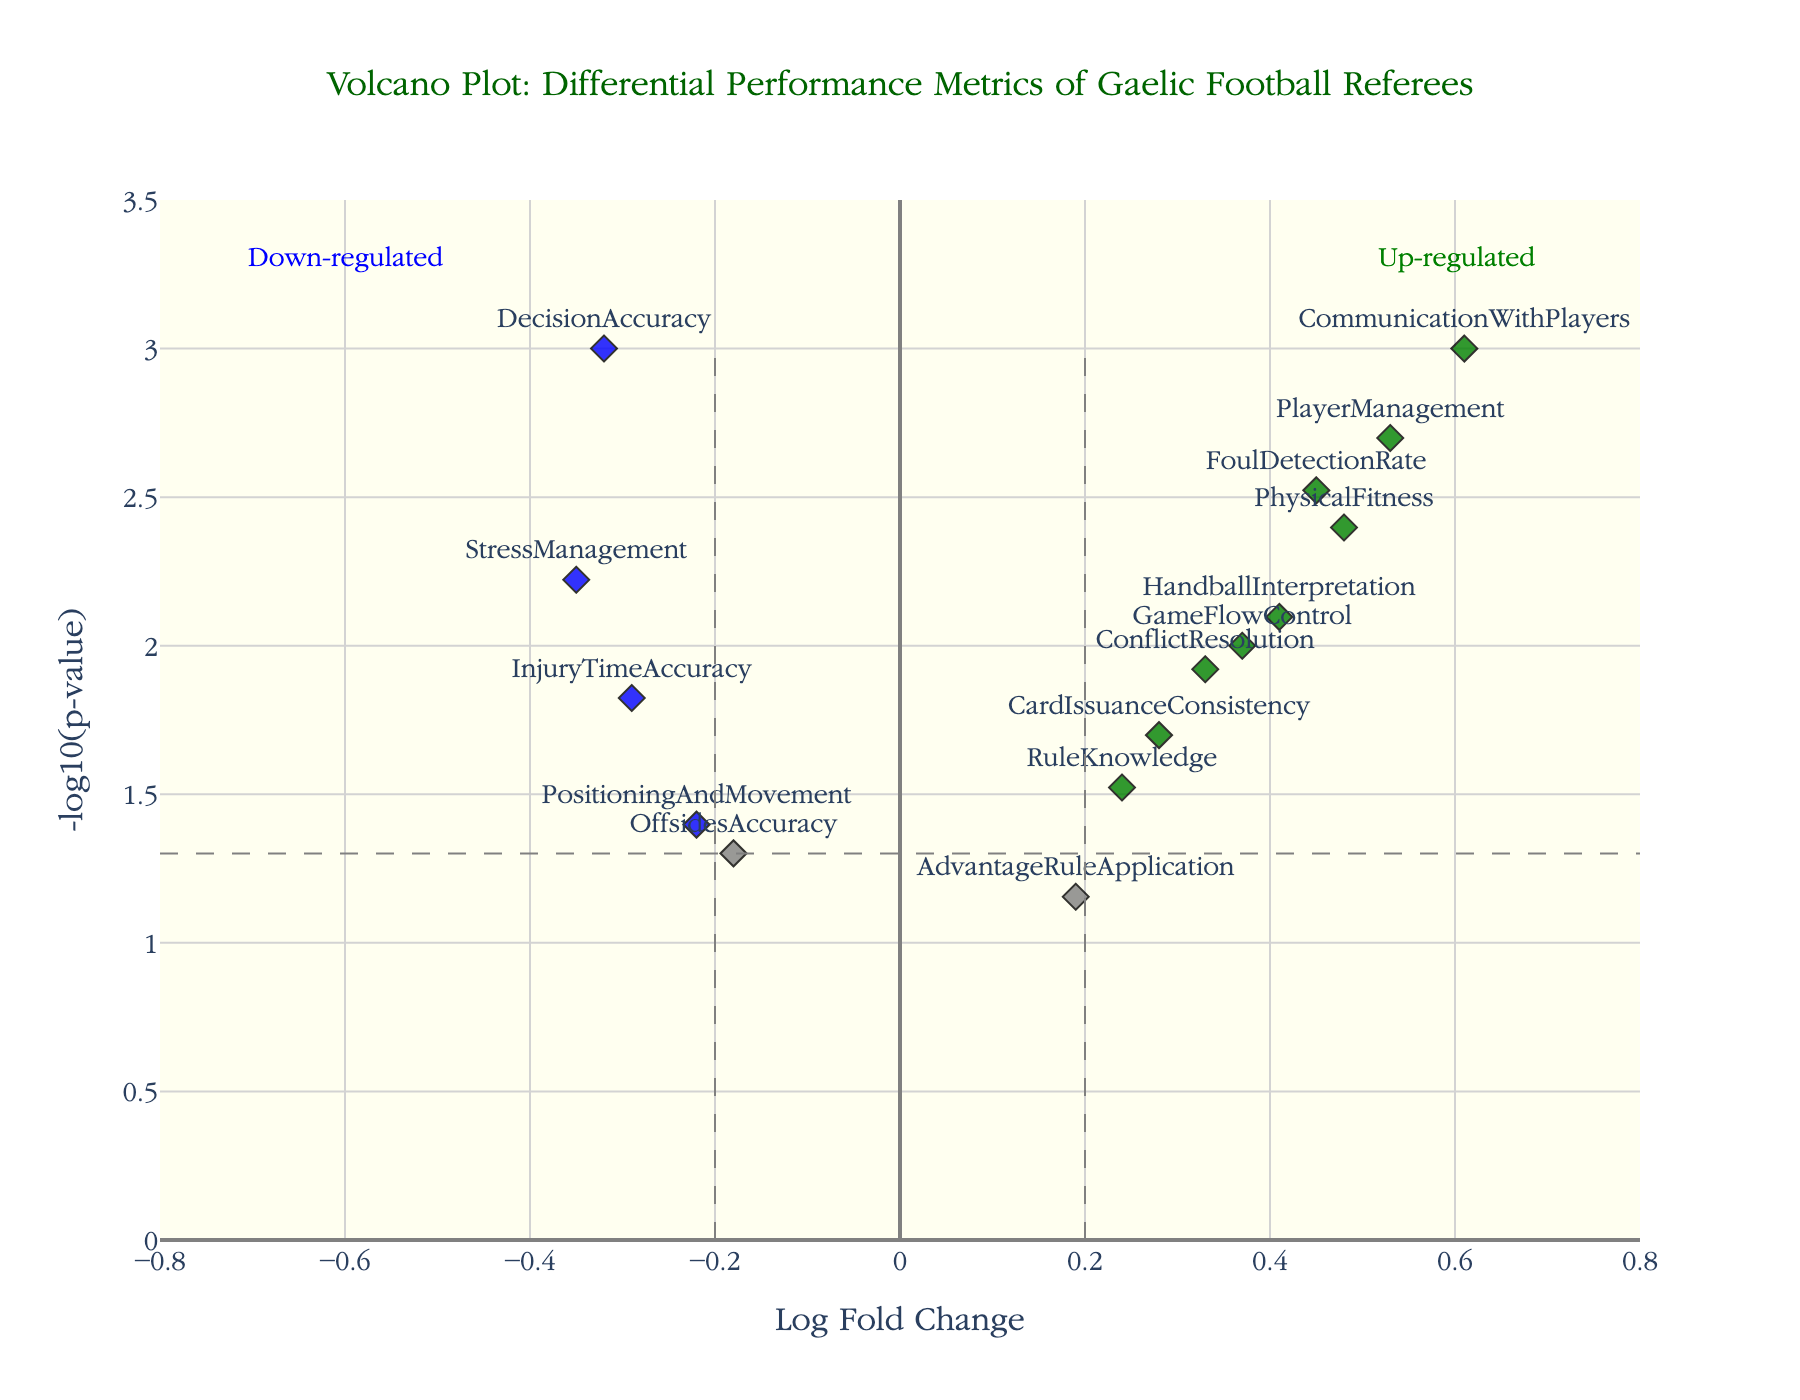What's the title of the plot? The title is located at the top of the plot, and it reads "Volcano Plot: Differential Performance Metrics of Gaelic Football Referees".
Answer: Volcano Plot: Differential Performance Metrics of Gaelic Football Referees How many metrics are plotted in total? Each diamond marker represents one referee metric. By counting the markers, we find there are 15 metrics in total.
Answer: 15 Which metric exhibits the highest Log Fold Change? To find the metric with the highest Log Fold Change, look for the point farthest to the right on the x-axis. The furthest point to the right is "CommunicationWithPlayers".
Answer: CommunicationWithPlayers Are there any metrics that are significantly down-regulated? If so, name one. Significant down-regulation can be identified by blue points located to the far left of the plot with Log Fold Change values less than -0.2 and p-values less than 0.05. One of these metrics is "StressManagement".
Answer: StressManagement Which metric has the lowest p-value and what does it signify? The lowest p-value corresponds to the highest point on the y-axis, which is the point "CommunicationWithPlayers" located at the top of the plot. This signifies the metric is the most statistically significant.
Answer: CommunicationWithPlayers What color indicates metrics with significant up-regulation? The plot differentiates up-regulated metrics with green color.
Answer: Green How many metrics are significantly up-regulated? Significantly up-regulated metrics are marked in green color with Log Fold Change values greater than 0.2 and p-values less than 0.05. By counting these points, there are 5 metrics.
Answer: 5 Compare the Log Fold Change of "CardIssuanceConsistency" and "RuleKnowledge". Which one is higher? By locating both metrics on the x-axis, "CardIssuanceConsistency" (0.28) has a higher Log Fold Change than "RuleKnowledge" (0.24).
Answer: CardIssuanceConsistency Which metric shows a greater significance between "PlayerManagement" and "PhysicalFitness"? Greater significance corresponds to a higher -log10(p-value). Comparing the y-axis positions, "PlayerManagement" is higher than "PhysicalFitness".
Answer: PlayerManagement For the metric "FoulDetectionRate", what are the Log Fold Change and p-value? The hover text or positions in the plot show that "FoulDetectionRate" has a Log Fold Change of 0.45 and a p-value of 0.003.
Answer: 0.45, 0.003 